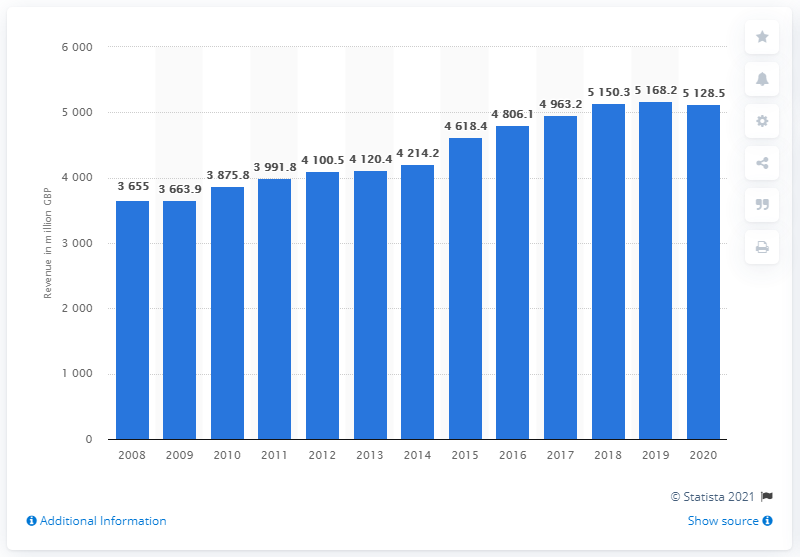Indicate a few pertinent items in this graphic. In 2017, the revenue of Virgin Media Inc was approximately 4,963.2. Virgin Media generated revenue of £5128.5 million in 2020. 